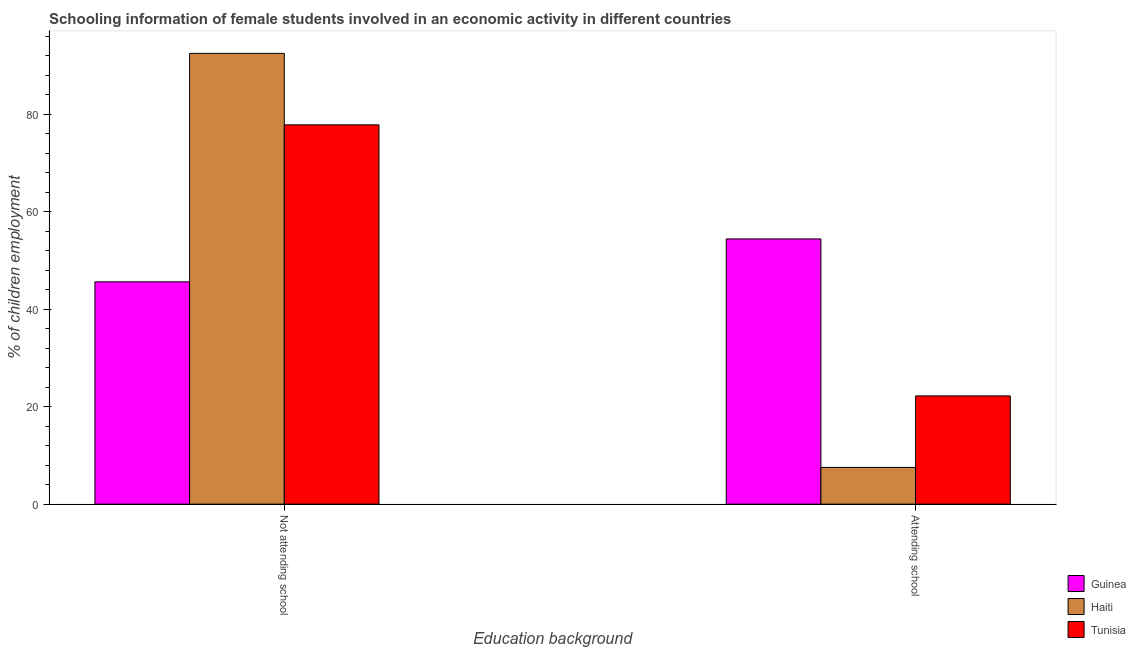How many bars are there on the 2nd tick from the left?
Keep it short and to the point. 3. How many bars are there on the 1st tick from the right?
Provide a short and direct response. 3. What is the label of the 1st group of bars from the left?
Your answer should be compact. Not attending school. What is the percentage of employed females who are not attending school in Tunisia?
Provide a succinct answer. 77.8. Across all countries, what is the maximum percentage of employed females who are not attending school?
Provide a succinct answer. 92.46. Across all countries, what is the minimum percentage of employed females who are attending school?
Your answer should be compact. 7.54. In which country was the percentage of employed females who are not attending school maximum?
Provide a short and direct response. Haiti. In which country was the percentage of employed females who are not attending school minimum?
Your response must be concise. Guinea. What is the total percentage of employed females who are not attending school in the graph?
Offer a terse response. 215.86. What is the difference between the percentage of employed females who are attending school in Tunisia and that in Haiti?
Keep it short and to the point. 14.66. What is the difference between the percentage of employed females who are attending school in Guinea and the percentage of employed females who are not attending school in Tunisia?
Your answer should be very brief. -23.4. What is the average percentage of employed females who are not attending school per country?
Give a very brief answer. 71.95. What is the difference between the percentage of employed females who are not attending school and percentage of employed females who are attending school in Tunisia?
Your response must be concise. 55.6. What is the ratio of the percentage of employed females who are not attending school in Haiti to that in Tunisia?
Your answer should be compact. 1.19. In how many countries, is the percentage of employed females who are attending school greater than the average percentage of employed females who are attending school taken over all countries?
Make the answer very short. 1. What does the 3rd bar from the left in Not attending school represents?
Your answer should be very brief. Tunisia. What does the 1st bar from the right in Not attending school represents?
Give a very brief answer. Tunisia. How many bars are there?
Provide a short and direct response. 6. How many countries are there in the graph?
Provide a short and direct response. 3. Are the values on the major ticks of Y-axis written in scientific E-notation?
Your answer should be very brief. No. Does the graph contain any zero values?
Make the answer very short. No. How many legend labels are there?
Make the answer very short. 3. What is the title of the graph?
Your answer should be very brief. Schooling information of female students involved in an economic activity in different countries. What is the label or title of the X-axis?
Your response must be concise. Education background. What is the label or title of the Y-axis?
Give a very brief answer. % of children employment. What is the % of children employment of Guinea in Not attending school?
Ensure brevity in your answer.  45.6. What is the % of children employment of Haiti in Not attending school?
Your answer should be compact. 92.46. What is the % of children employment of Tunisia in Not attending school?
Provide a succinct answer. 77.8. What is the % of children employment of Guinea in Attending school?
Offer a very short reply. 54.4. What is the % of children employment in Haiti in Attending school?
Your answer should be very brief. 7.54. Across all Education background, what is the maximum % of children employment in Guinea?
Offer a terse response. 54.4. Across all Education background, what is the maximum % of children employment in Haiti?
Ensure brevity in your answer.  92.46. Across all Education background, what is the maximum % of children employment in Tunisia?
Offer a very short reply. 77.8. Across all Education background, what is the minimum % of children employment in Guinea?
Your response must be concise. 45.6. Across all Education background, what is the minimum % of children employment of Haiti?
Keep it short and to the point. 7.54. Across all Education background, what is the minimum % of children employment in Tunisia?
Your response must be concise. 22.2. What is the total % of children employment of Tunisia in the graph?
Ensure brevity in your answer.  100. What is the difference between the % of children employment in Haiti in Not attending school and that in Attending school?
Give a very brief answer. 84.93. What is the difference between the % of children employment in Tunisia in Not attending school and that in Attending school?
Provide a succinct answer. 55.6. What is the difference between the % of children employment in Guinea in Not attending school and the % of children employment in Haiti in Attending school?
Provide a short and direct response. 38.06. What is the difference between the % of children employment of Guinea in Not attending school and the % of children employment of Tunisia in Attending school?
Offer a terse response. 23.4. What is the difference between the % of children employment in Haiti in Not attending school and the % of children employment in Tunisia in Attending school?
Ensure brevity in your answer.  70.26. What is the average % of children employment in Tunisia per Education background?
Offer a very short reply. 50. What is the difference between the % of children employment in Guinea and % of children employment in Haiti in Not attending school?
Your answer should be compact. -46.86. What is the difference between the % of children employment of Guinea and % of children employment of Tunisia in Not attending school?
Provide a succinct answer. -32.2. What is the difference between the % of children employment in Haiti and % of children employment in Tunisia in Not attending school?
Ensure brevity in your answer.  14.66. What is the difference between the % of children employment of Guinea and % of children employment of Haiti in Attending school?
Your answer should be compact. 46.86. What is the difference between the % of children employment of Guinea and % of children employment of Tunisia in Attending school?
Your response must be concise. 32.2. What is the difference between the % of children employment in Haiti and % of children employment in Tunisia in Attending school?
Make the answer very short. -14.66. What is the ratio of the % of children employment of Guinea in Not attending school to that in Attending school?
Ensure brevity in your answer.  0.84. What is the ratio of the % of children employment in Haiti in Not attending school to that in Attending school?
Your response must be concise. 12.27. What is the ratio of the % of children employment of Tunisia in Not attending school to that in Attending school?
Provide a succinct answer. 3.5. What is the difference between the highest and the second highest % of children employment in Haiti?
Give a very brief answer. 84.93. What is the difference between the highest and the second highest % of children employment of Tunisia?
Give a very brief answer. 55.6. What is the difference between the highest and the lowest % of children employment in Guinea?
Keep it short and to the point. 8.8. What is the difference between the highest and the lowest % of children employment of Haiti?
Offer a terse response. 84.93. What is the difference between the highest and the lowest % of children employment in Tunisia?
Provide a succinct answer. 55.6. 